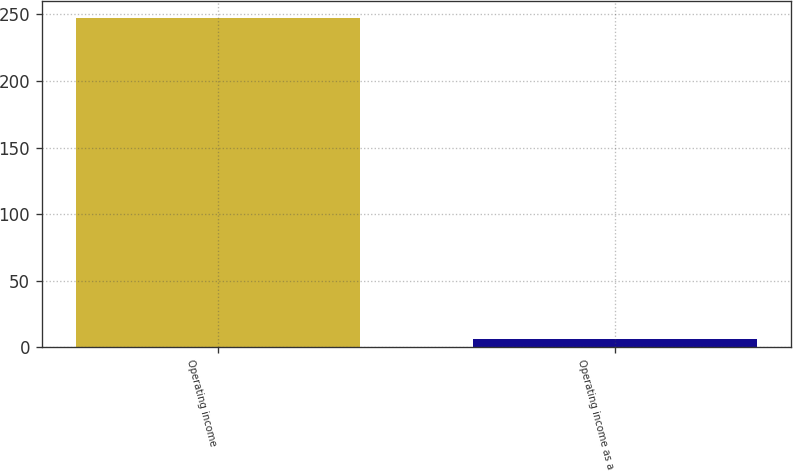Convert chart to OTSL. <chart><loc_0><loc_0><loc_500><loc_500><bar_chart><fcel>Operating income<fcel>Operating income as a<nl><fcel>247.5<fcel>6.5<nl></chart> 